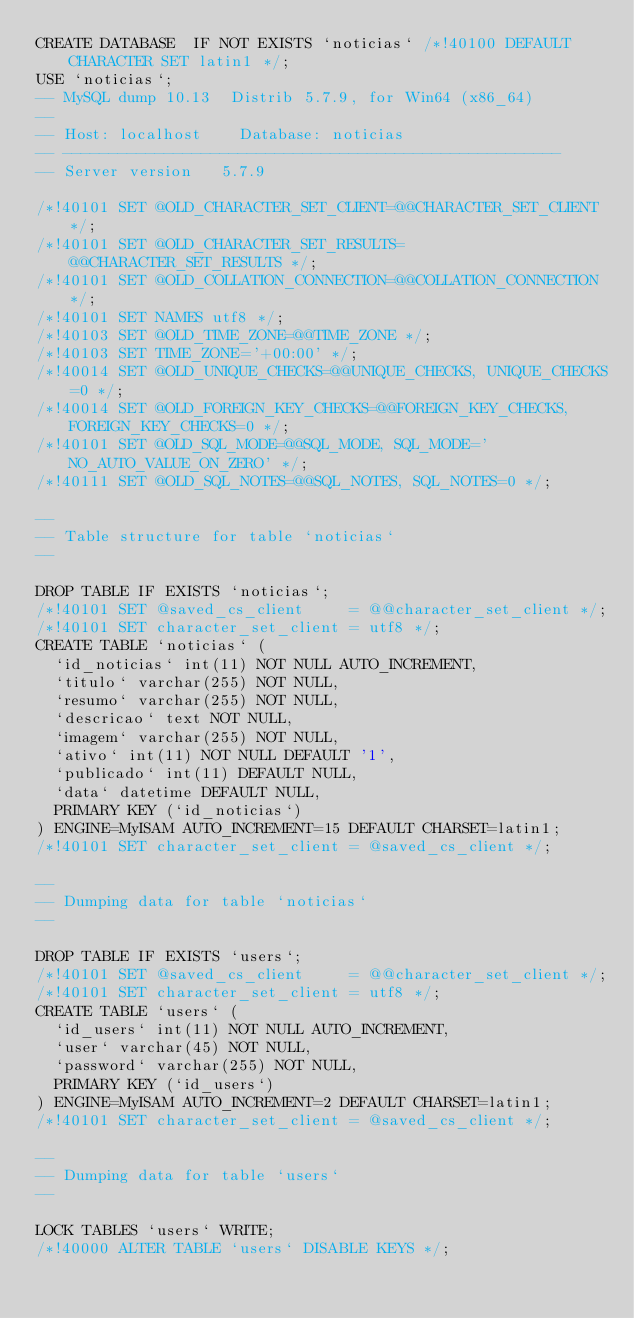Convert code to text. <code><loc_0><loc_0><loc_500><loc_500><_SQL_>CREATE DATABASE  IF NOT EXISTS `noticias` /*!40100 DEFAULT CHARACTER SET latin1 */;
USE `noticias`;
-- MySQL dump 10.13  Distrib 5.7.9, for Win64 (x86_64)
--
-- Host: localhost    Database: noticias
-- ------------------------------------------------------
-- Server version	5.7.9

/*!40101 SET @OLD_CHARACTER_SET_CLIENT=@@CHARACTER_SET_CLIENT */;
/*!40101 SET @OLD_CHARACTER_SET_RESULTS=@@CHARACTER_SET_RESULTS */;
/*!40101 SET @OLD_COLLATION_CONNECTION=@@COLLATION_CONNECTION */;
/*!40101 SET NAMES utf8 */;
/*!40103 SET @OLD_TIME_ZONE=@@TIME_ZONE */;
/*!40103 SET TIME_ZONE='+00:00' */;
/*!40014 SET @OLD_UNIQUE_CHECKS=@@UNIQUE_CHECKS, UNIQUE_CHECKS=0 */;
/*!40014 SET @OLD_FOREIGN_KEY_CHECKS=@@FOREIGN_KEY_CHECKS, FOREIGN_KEY_CHECKS=0 */;
/*!40101 SET @OLD_SQL_MODE=@@SQL_MODE, SQL_MODE='NO_AUTO_VALUE_ON_ZERO' */;
/*!40111 SET @OLD_SQL_NOTES=@@SQL_NOTES, SQL_NOTES=0 */;

--
-- Table structure for table `noticias`
--

DROP TABLE IF EXISTS `noticias`;
/*!40101 SET @saved_cs_client     = @@character_set_client */;
/*!40101 SET character_set_client = utf8 */;
CREATE TABLE `noticias` (
  `id_noticias` int(11) NOT NULL AUTO_INCREMENT,
  `titulo` varchar(255) NOT NULL,
  `resumo` varchar(255) NOT NULL,
  `descricao` text NOT NULL,
  `imagem` varchar(255) NOT NULL,
  `ativo` int(11) NOT NULL DEFAULT '1',
  `publicado` int(11) DEFAULT NULL,
  `data` datetime DEFAULT NULL,
  PRIMARY KEY (`id_noticias`)
) ENGINE=MyISAM AUTO_INCREMENT=15 DEFAULT CHARSET=latin1;
/*!40101 SET character_set_client = @saved_cs_client */;

--
-- Dumping data for table `noticias`
--

DROP TABLE IF EXISTS `users`;
/*!40101 SET @saved_cs_client     = @@character_set_client */;
/*!40101 SET character_set_client = utf8 */;
CREATE TABLE `users` (
  `id_users` int(11) NOT NULL AUTO_INCREMENT,
  `user` varchar(45) NOT NULL,
  `password` varchar(255) NOT NULL,
  PRIMARY KEY (`id_users`)
) ENGINE=MyISAM AUTO_INCREMENT=2 DEFAULT CHARSET=latin1;
/*!40101 SET character_set_client = @saved_cs_client */;

--
-- Dumping data for table `users`
--

LOCK TABLES `users` WRITE;
/*!40000 ALTER TABLE `users` DISABLE KEYS */;</code> 